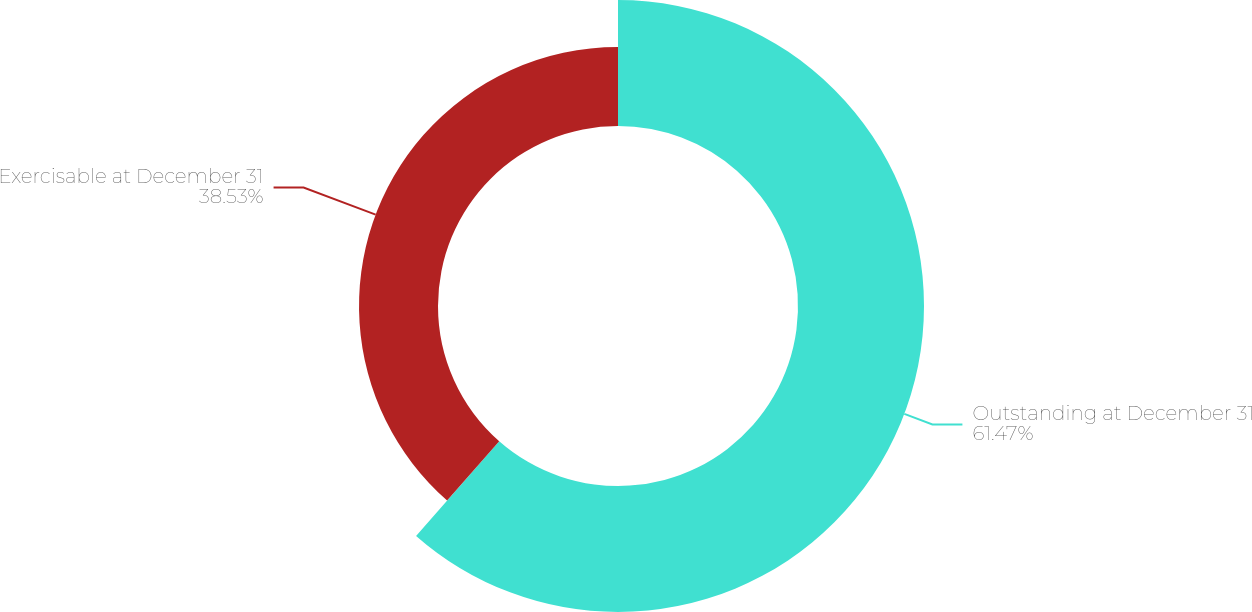Convert chart to OTSL. <chart><loc_0><loc_0><loc_500><loc_500><pie_chart><fcel>Outstanding at December 31<fcel>Exercisable at December 31<nl><fcel>61.47%<fcel>38.53%<nl></chart> 